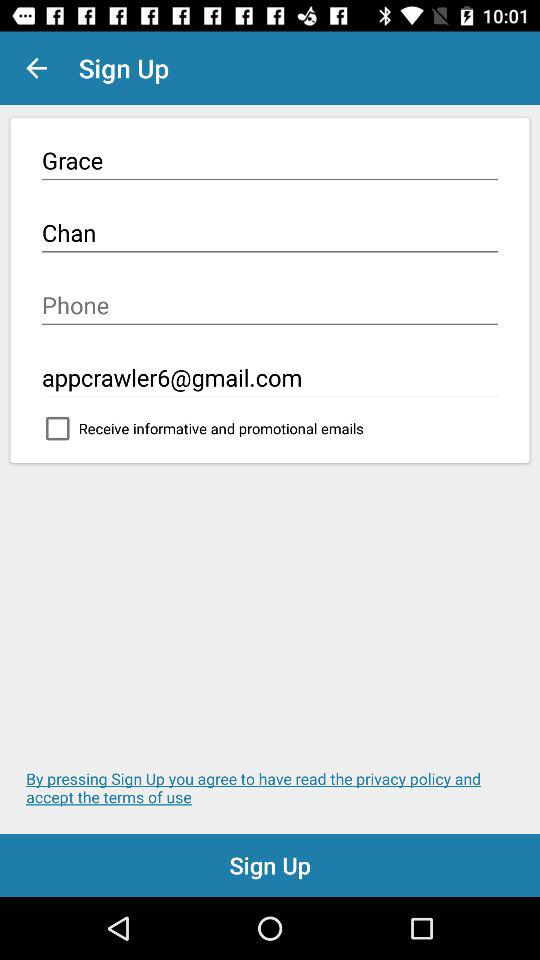What is the first name used to sign up? The first name used to sign up is Grace. 